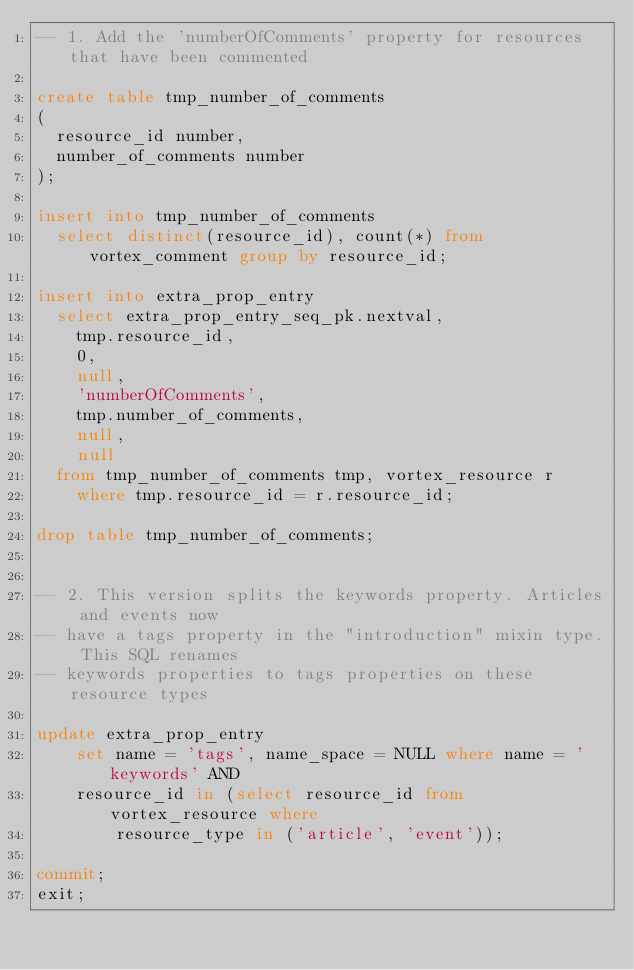<code> <loc_0><loc_0><loc_500><loc_500><_SQL_>-- 1. Add the 'numberOfComments' property for resources that have been commented

create table tmp_number_of_comments
(
  resource_id number,
  number_of_comments number
);

insert into tmp_number_of_comments
  select distinct(resource_id), count(*) from vortex_comment group by resource_id;

insert into extra_prop_entry
  select extra_prop_entry_seq_pk.nextval,
    tmp.resource_id,
    0,
    null,
    'numberOfComments',
    tmp.number_of_comments,
    null,
    null
  from tmp_number_of_comments tmp, vortex_resource r
    where tmp.resource_id = r.resource_id;

drop table tmp_number_of_comments;


-- 2. This version splits the keywords property. Articles and events now
-- have a tags property in the "introduction" mixin type. This SQL renames
-- keywords properties to tags properties on these resource types

update extra_prop_entry
    set name = 'tags', name_space = NULL where name = 'keywords' AND
    resource_id in (select resource_id from vortex_resource where 
        resource_type in ('article', 'event'));

commit;
exit;
</code> 